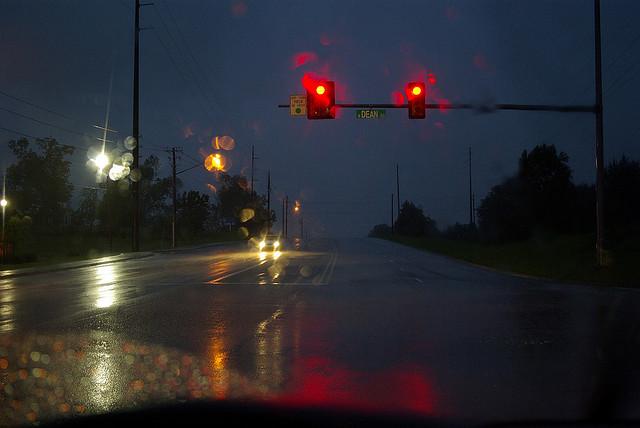What color are the lights?
Give a very brief answer. Red. Is it a nice night out?
Give a very brief answer. No. Is the photo taken place in the daytime?
Give a very brief answer. No. What are the lights?
Write a very short answer. Red. Is it raining?
Quick response, please. Yes. Should the car stop or keep going?
Short answer required. Stop. Where are the traffic lights?
Answer briefly. On pole. 